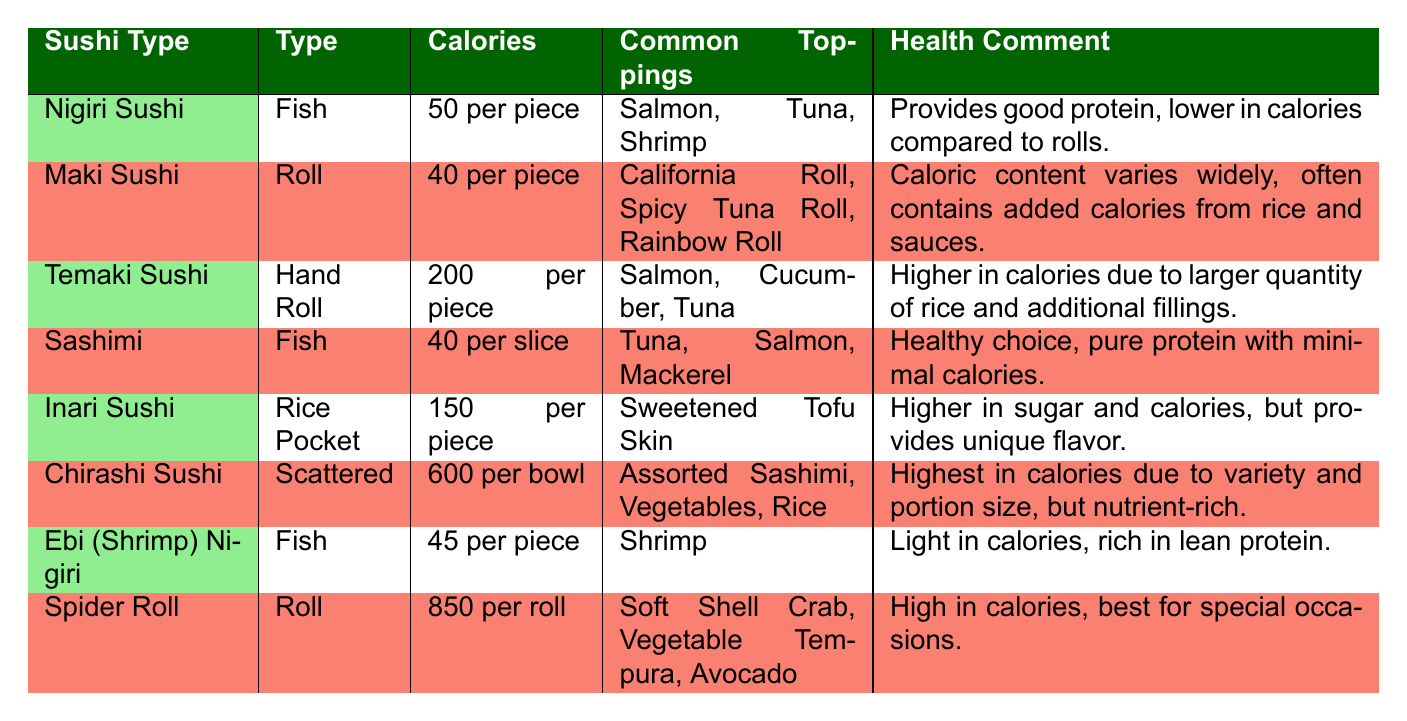What is the caloric content of Sashimi? According to the table, Sashimi has a caloric content of 40 per slice.
Answer: 40 per slice Which type of sushi has the highest caloric content? The table indicates that Chirashi Sushi has a caloric content of 600 per bowl, which is the highest among all listed sushi types.
Answer: Chirashi Sushi How many calories does a Temaki Sushi piece contain? The table states that Temaki Sushi has a caloric content of 200 per piece.
Answer: 200 per piece Is Maki Sushi lower in calories than Nigiri Sushi? Yes, Maki Sushi has 40 calories per piece while Nigiri Sushi has 50 calories per piece, so Maki is lower in calories.
Answer: Yes What are the common toppings for Spider Roll? The table lists the common toppings for Spider Roll as Soft Shell Crab, Vegetable Tempura, and Avocado.
Answer: Soft Shell Crab, Vegetable Tempura, Avocado What is the average caloric content of fish sushi types? The fish-type sushi (Nigiri Sushi, Sashimi, Ebi Nigiri) has the following caloric contents: 50, 40, and 45 respectively. The total is 135, and there are 3 types, so the average is 135/3 = 45.
Answer: 45 How many calories does a roll of Spider Sushi contain compared to Temaki Sushi? The table shows that Spider Roll has 850 calories per roll, while Temaki Sushi has 200 calories per piece. This comparison shows that Spider Roll is significantly higher in calories than Temaki Sushi.
Answer: Spider Roll is higher Are there any sushi types with a caloric content under 50? Yes, both Maki Sushi (40 per piece) and Sashimi (40 per slice) have a caloric content under 50.
Answer: Yes What is the caloric difference between Inari Sushi and Ebi Nigiri? Inari Sushi has 150 calories per piece and Ebi Nigiri has 45 calories per piece. The difference is 150 - 45 = 105 calories, meaning Inari Sushi is higher by that amount.
Answer: 105 calories 